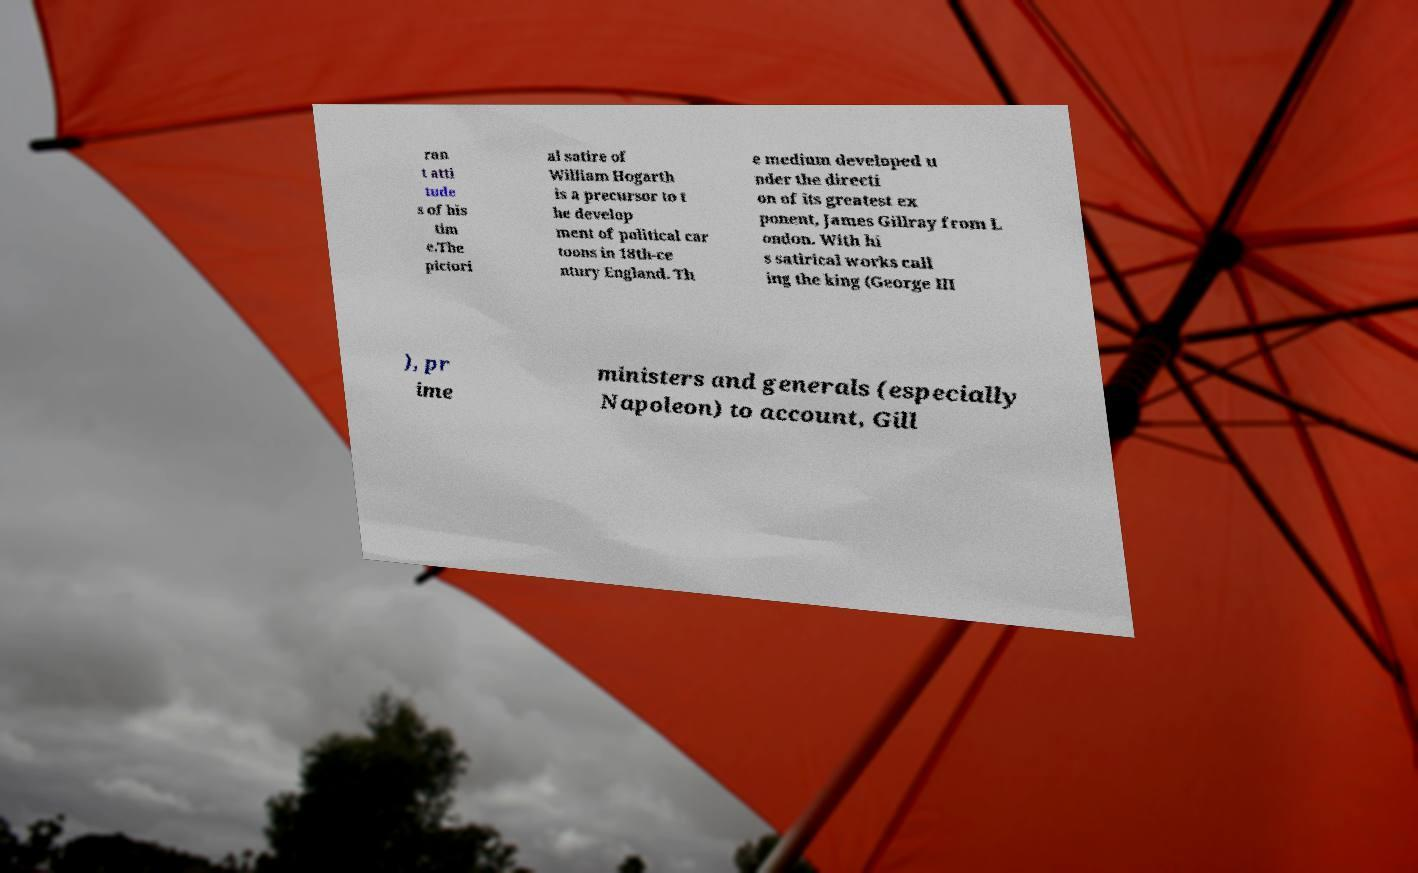Could you assist in decoding the text presented in this image and type it out clearly? ran t atti tude s of his tim e.The pictori al satire of William Hogarth is a precursor to t he develop ment of political car toons in 18th-ce ntury England. Th e medium developed u nder the directi on of its greatest ex ponent, James Gillray from L ondon. With hi s satirical works call ing the king (George III ), pr ime ministers and generals (especially Napoleon) to account, Gill 